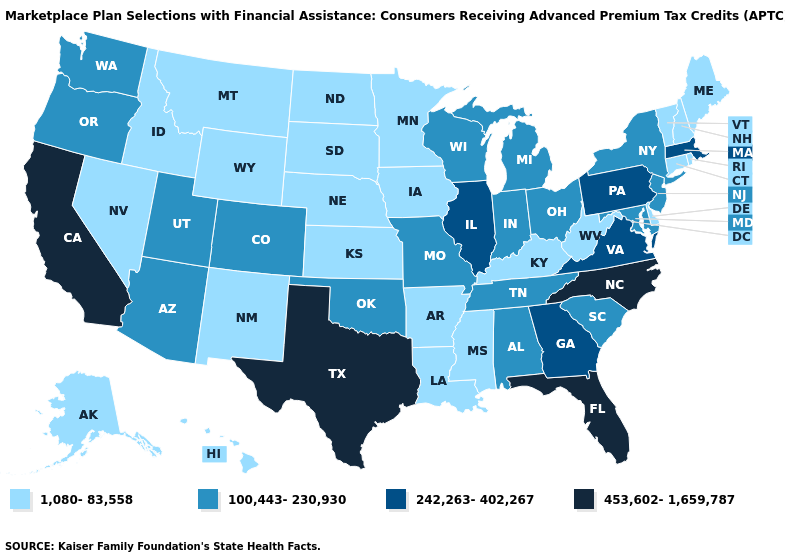Among the states that border Montana , which have the lowest value?
Concise answer only. Idaho, North Dakota, South Dakota, Wyoming. What is the value of Minnesota?
Write a very short answer. 1,080-83,558. Which states have the highest value in the USA?
Concise answer only. California, Florida, North Carolina, Texas. Which states have the lowest value in the South?
Give a very brief answer. Arkansas, Delaware, Kentucky, Louisiana, Mississippi, West Virginia. What is the value of California?
Concise answer only. 453,602-1,659,787. What is the lowest value in states that border Nebraska?
Quick response, please. 1,080-83,558. Name the states that have a value in the range 100,443-230,930?
Concise answer only. Alabama, Arizona, Colorado, Indiana, Maryland, Michigan, Missouri, New Jersey, New York, Ohio, Oklahoma, Oregon, South Carolina, Tennessee, Utah, Washington, Wisconsin. Does the map have missing data?
Be succinct. No. Name the states that have a value in the range 1,080-83,558?
Answer briefly. Alaska, Arkansas, Connecticut, Delaware, Hawaii, Idaho, Iowa, Kansas, Kentucky, Louisiana, Maine, Minnesota, Mississippi, Montana, Nebraska, Nevada, New Hampshire, New Mexico, North Dakota, Rhode Island, South Dakota, Vermont, West Virginia, Wyoming. Name the states that have a value in the range 242,263-402,267?
Short answer required. Georgia, Illinois, Massachusetts, Pennsylvania, Virginia. Does Washington have a lower value than Wyoming?
Give a very brief answer. No. What is the lowest value in states that border Louisiana?
Be succinct. 1,080-83,558. Name the states that have a value in the range 453,602-1,659,787?
Keep it brief. California, Florida, North Carolina, Texas. Does Pennsylvania have the highest value in the USA?
Quick response, please. No. 